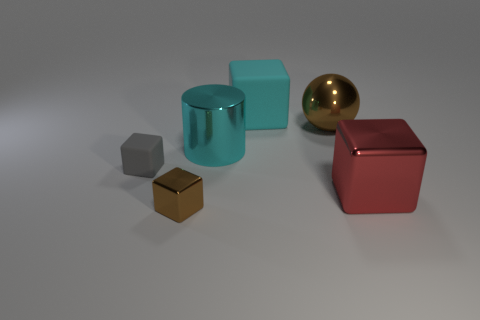Are there fewer big red blocks that are to the left of the big ball than red blocks?
Your response must be concise. Yes. What is the shape of the small matte object?
Your answer should be compact. Cube. What is the size of the matte thing that is in front of the ball?
Offer a very short reply. Small. There is a ball that is the same size as the cyan matte object; what color is it?
Offer a very short reply. Brown. Is there a large block that has the same color as the big cylinder?
Your answer should be compact. Yes. Is the number of cyan shiny cylinders behind the tiny brown thing less than the number of spheres left of the large cyan shiny cylinder?
Make the answer very short. No. The object that is on the right side of the brown cube and in front of the big cyan shiny thing is made of what material?
Provide a succinct answer. Metal. Do the big red metallic object and the brown thing that is on the left side of the large cyan metallic thing have the same shape?
Give a very brief answer. Yes. What number of other objects are the same size as the brown block?
Provide a succinct answer. 1. Is the number of rubber cubes greater than the number of tiny green matte objects?
Your answer should be very brief. Yes. 